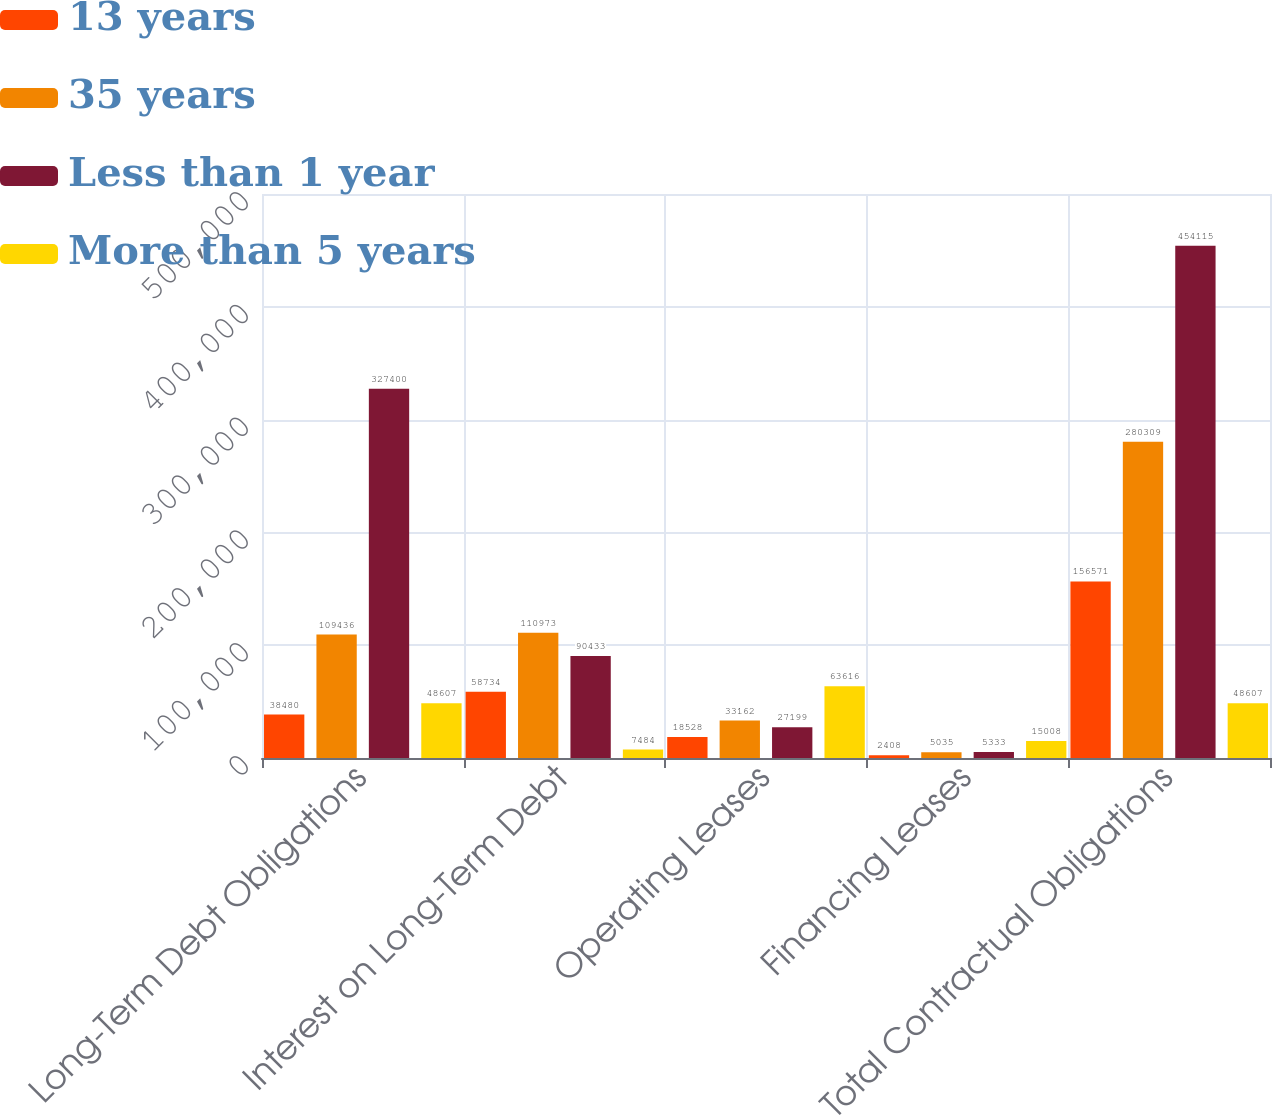Convert chart to OTSL. <chart><loc_0><loc_0><loc_500><loc_500><stacked_bar_chart><ecel><fcel>Long-Term Debt Obligations<fcel>Interest on Long-Term Debt<fcel>Operating Leases<fcel>Financing Leases<fcel>Total Contractual Obligations<nl><fcel>13 years<fcel>38480<fcel>58734<fcel>18528<fcel>2408<fcel>156571<nl><fcel>35 years<fcel>109436<fcel>110973<fcel>33162<fcel>5035<fcel>280309<nl><fcel>Less than 1 year<fcel>327400<fcel>90433<fcel>27199<fcel>5333<fcel>454115<nl><fcel>More than 5 years<fcel>48607<fcel>7484<fcel>63616<fcel>15008<fcel>48607<nl></chart> 